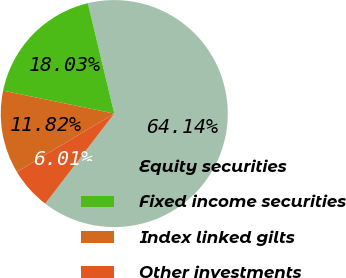Convert chart to OTSL. <chart><loc_0><loc_0><loc_500><loc_500><pie_chart><fcel>Equity securities<fcel>Fixed income securities<fcel>Index linked gilts<fcel>Other investments<nl><fcel>64.14%<fcel>18.03%<fcel>11.82%<fcel>6.01%<nl></chart> 